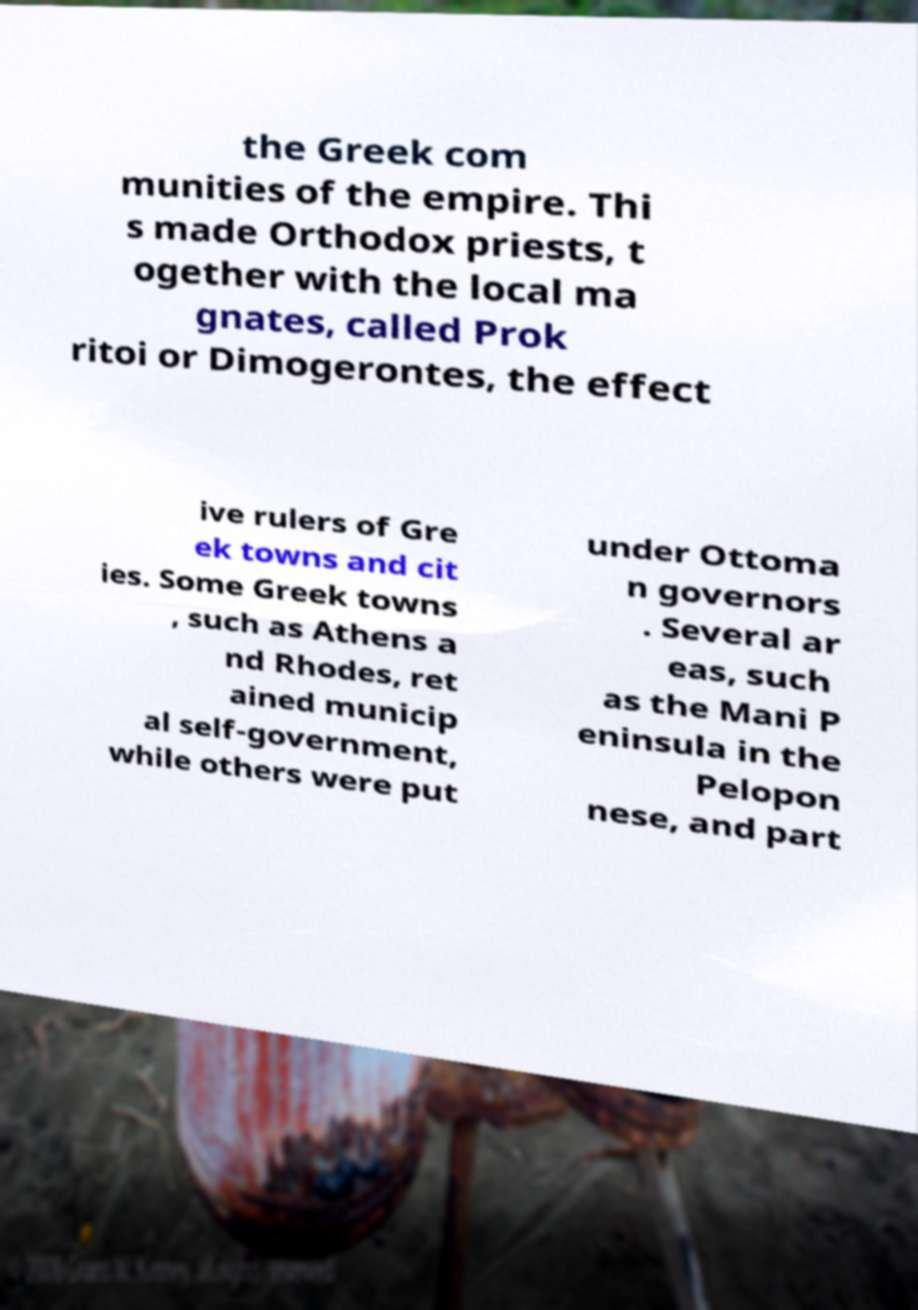There's text embedded in this image that I need extracted. Can you transcribe it verbatim? the Greek com munities of the empire. Thi s made Orthodox priests, t ogether with the local ma gnates, called Prok ritoi or Dimogerontes, the effect ive rulers of Gre ek towns and cit ies. Some Greek towns , such as Athens a nd Rhodes, ret ained municip al self-government, while others were put under Ottoma n governors . Several ar eas, such as the Mani P eninsula in the Pelopon nese, and part 